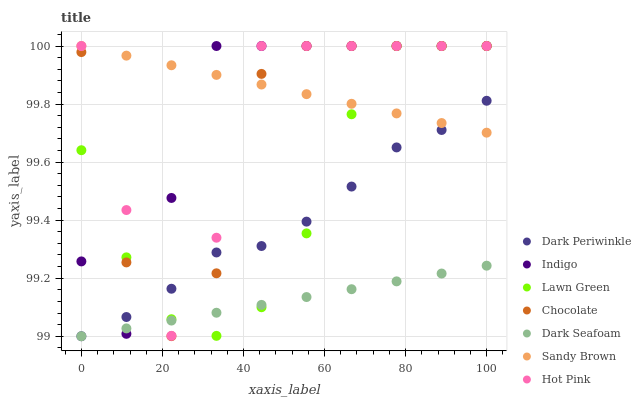Does Dark Seafoam have the minimum area under the curve?
Answer yes or no. Yes. Does Sandy Brown have the maximum area under the curve?
Answer yes or no. Yes. Does Indigo have the minimum area under the curve?
Answer yes or no. No. Does Indigo have the maximum area under the curve?
Answer yes or no. No. Is Sandy Brown the smoothest?
Answer yes or no. Yes. Is Chocolate the roughest?
Answer yes or no. Yes. Is Indigo the smoothest?
Answer yes or no. No. Is Indigo the roughest?
Answer yes or no. No. Does Dark Seafoam have the lowest value?
Answer yes or no. Yes. Does Indigo have the lowest value?
Answer yes or no. No. Does Sandy Brown have the highest value?
Answer yes or no. Yes. Does Dark Seafoam have the highest value?
Answer yes or no. No. Is Dark Seafoam less than Sandy Brown?
Answer yes or no. Yes. Is Sandy Brown greater than Dark Seafoam?
Answer yes or no. Yes. Does Indigo intersect Dark Periwinkle?
Answer yes or no. Yes. Is Indigo less than Dark Periwinkle?
Answer yes or no. No. Is Indigo greater than Dark Periwinkle?
Answer yes or no. No. Does Dark Seafoam intersect Sandy Brown?
Answer yes or no. No. 